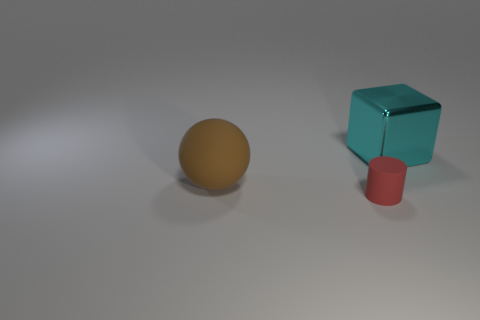What materials are the objects made of? The objects appear to have distinct textures suggesting different materials. The sphere looks matte and could be made of rubber, the cube appears to be metallic with a shiny surface, indicating it could be made of metal, and the cylinder has a less reflective, perhaps plastic-like surface. 